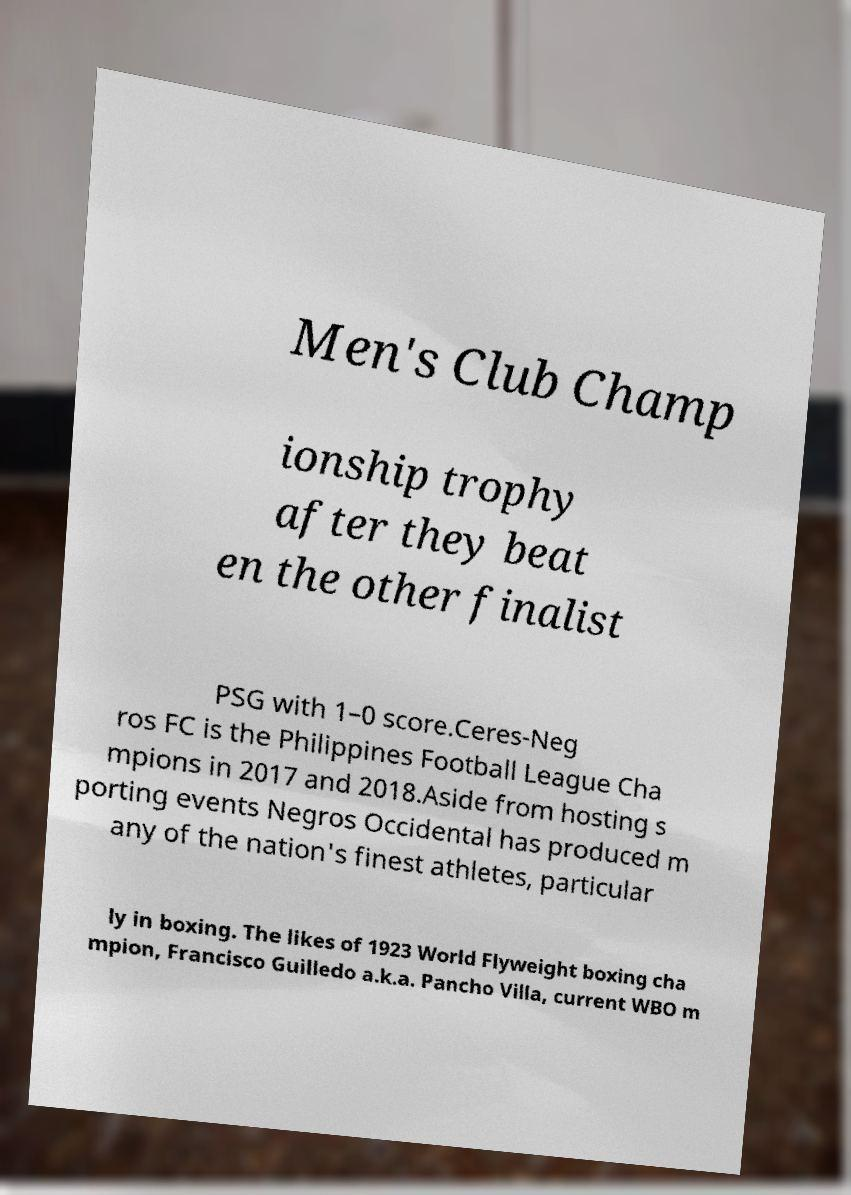Can you read and provide the text displayed in the image?This photo seems to have some interesting text. Can you extract and type it out for me? Men's Club Champ ionship trophy after they beat en the other finalist PSG with 1–0 score.Ceres-Neg ros FC is the Philippines Football League Cha mpions in 2017 and 2018.Aside from hosting s porting events Negros Occidental has produced m any of the nation's finest athletes, particular ly in boxing. The likes of 1923 World Flyweight boxing cha mpion, Francisco Guilledo a.k.a. Pancho Villa, current WBO m 